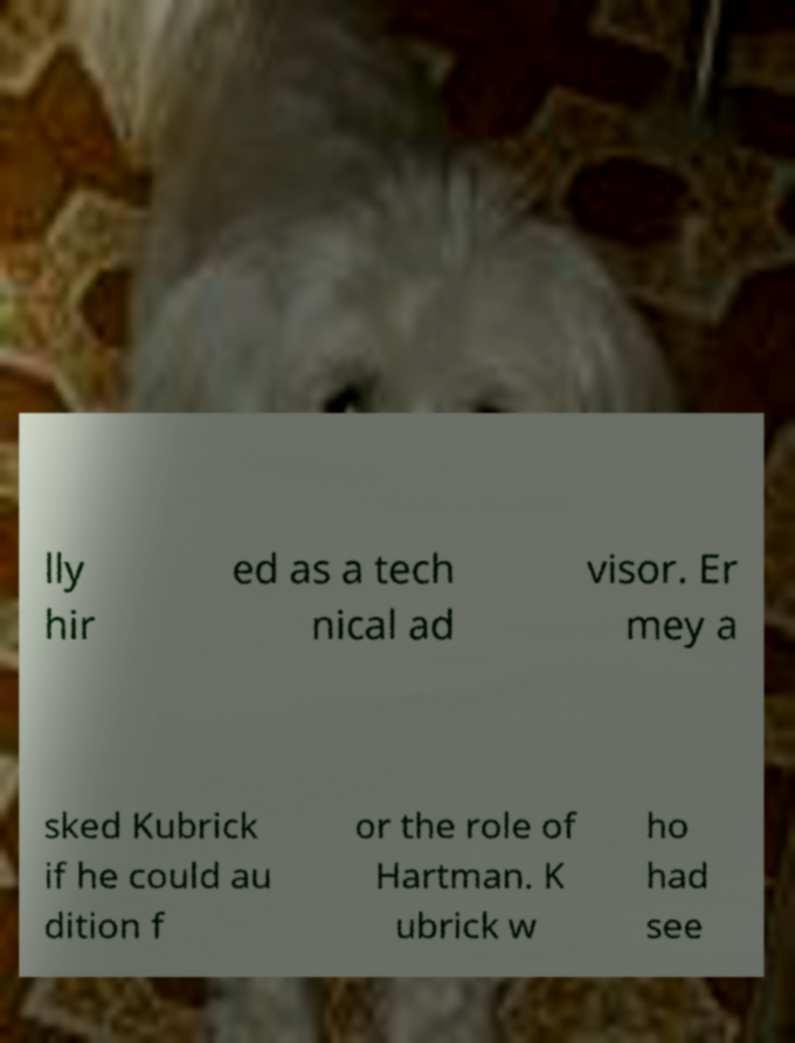What messages or text are displayed in this image? I need them in a readable, typed format. lly hir ed as a tech nical ad visor. Er mey a sked Kubrick if he could au dition f or the role of Hartman. K ubrick w ho had see 